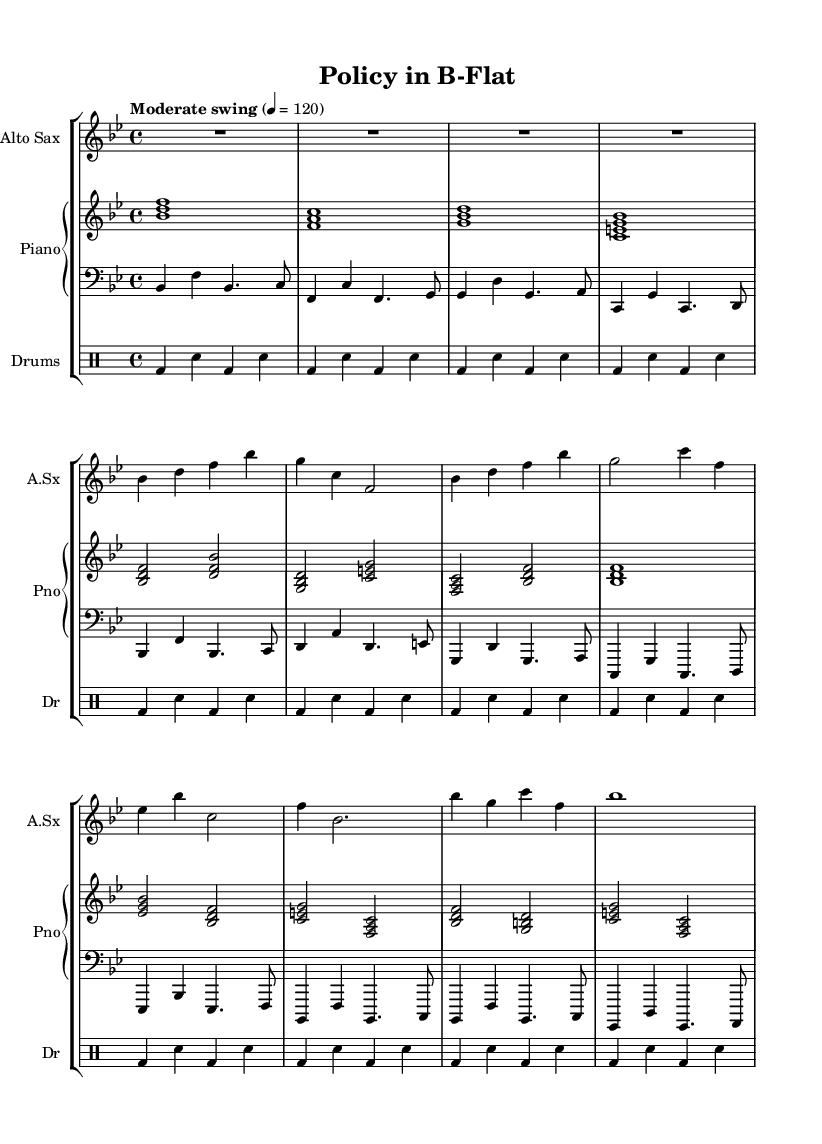What is the key signature of this music? The key signature is indicated at the beginning of the staff with two flats, which corresponds to B-flat major.
Answer: B-flat major What is the time signature of the piece? The time signature is placed at the beginning of the music, shown as a fraction with a 4 on top and a 4 on the bottom, indicating four beats per measure.
Answer: 4/4 What is the tempo marking for the piece? The tempo marking is noted above the staff as "Moderate swing" followed by a metronome marking of 120, which indicates the speed of the music.
Answer: Moderate swing, 120 How many measures are in the alto sax part? By counting each vertical bar line separating the sections of music, you can identify that there are ten measures present in the alto sax part.
Answer: 10 What is the rhythmic pattern of the drums in the first measure? The first measure of the drums shows the bass drum (bd) played on beats 1 and 3, with snare drum (sn) on beats 2 and 4, creating a common swing pattern.
Answer: Bass drum and snare pattern Which instrument plays the first chord in the piano part? Looking at the first note of the piano part, the first chord is played by the piano, specifically the voicing of B-flat, D, and F, which is indicated in the score.
Answer: Piano What is the unique characteristic of the fusion genre as demonstrated in this piece? This piece blends elements of public policy speeches with the improvisational nature of jazz, showcasing how dialogue can intertwine with musical expression through rhythm and melodic phrasing.
Answer: Blending speeches and jazz 